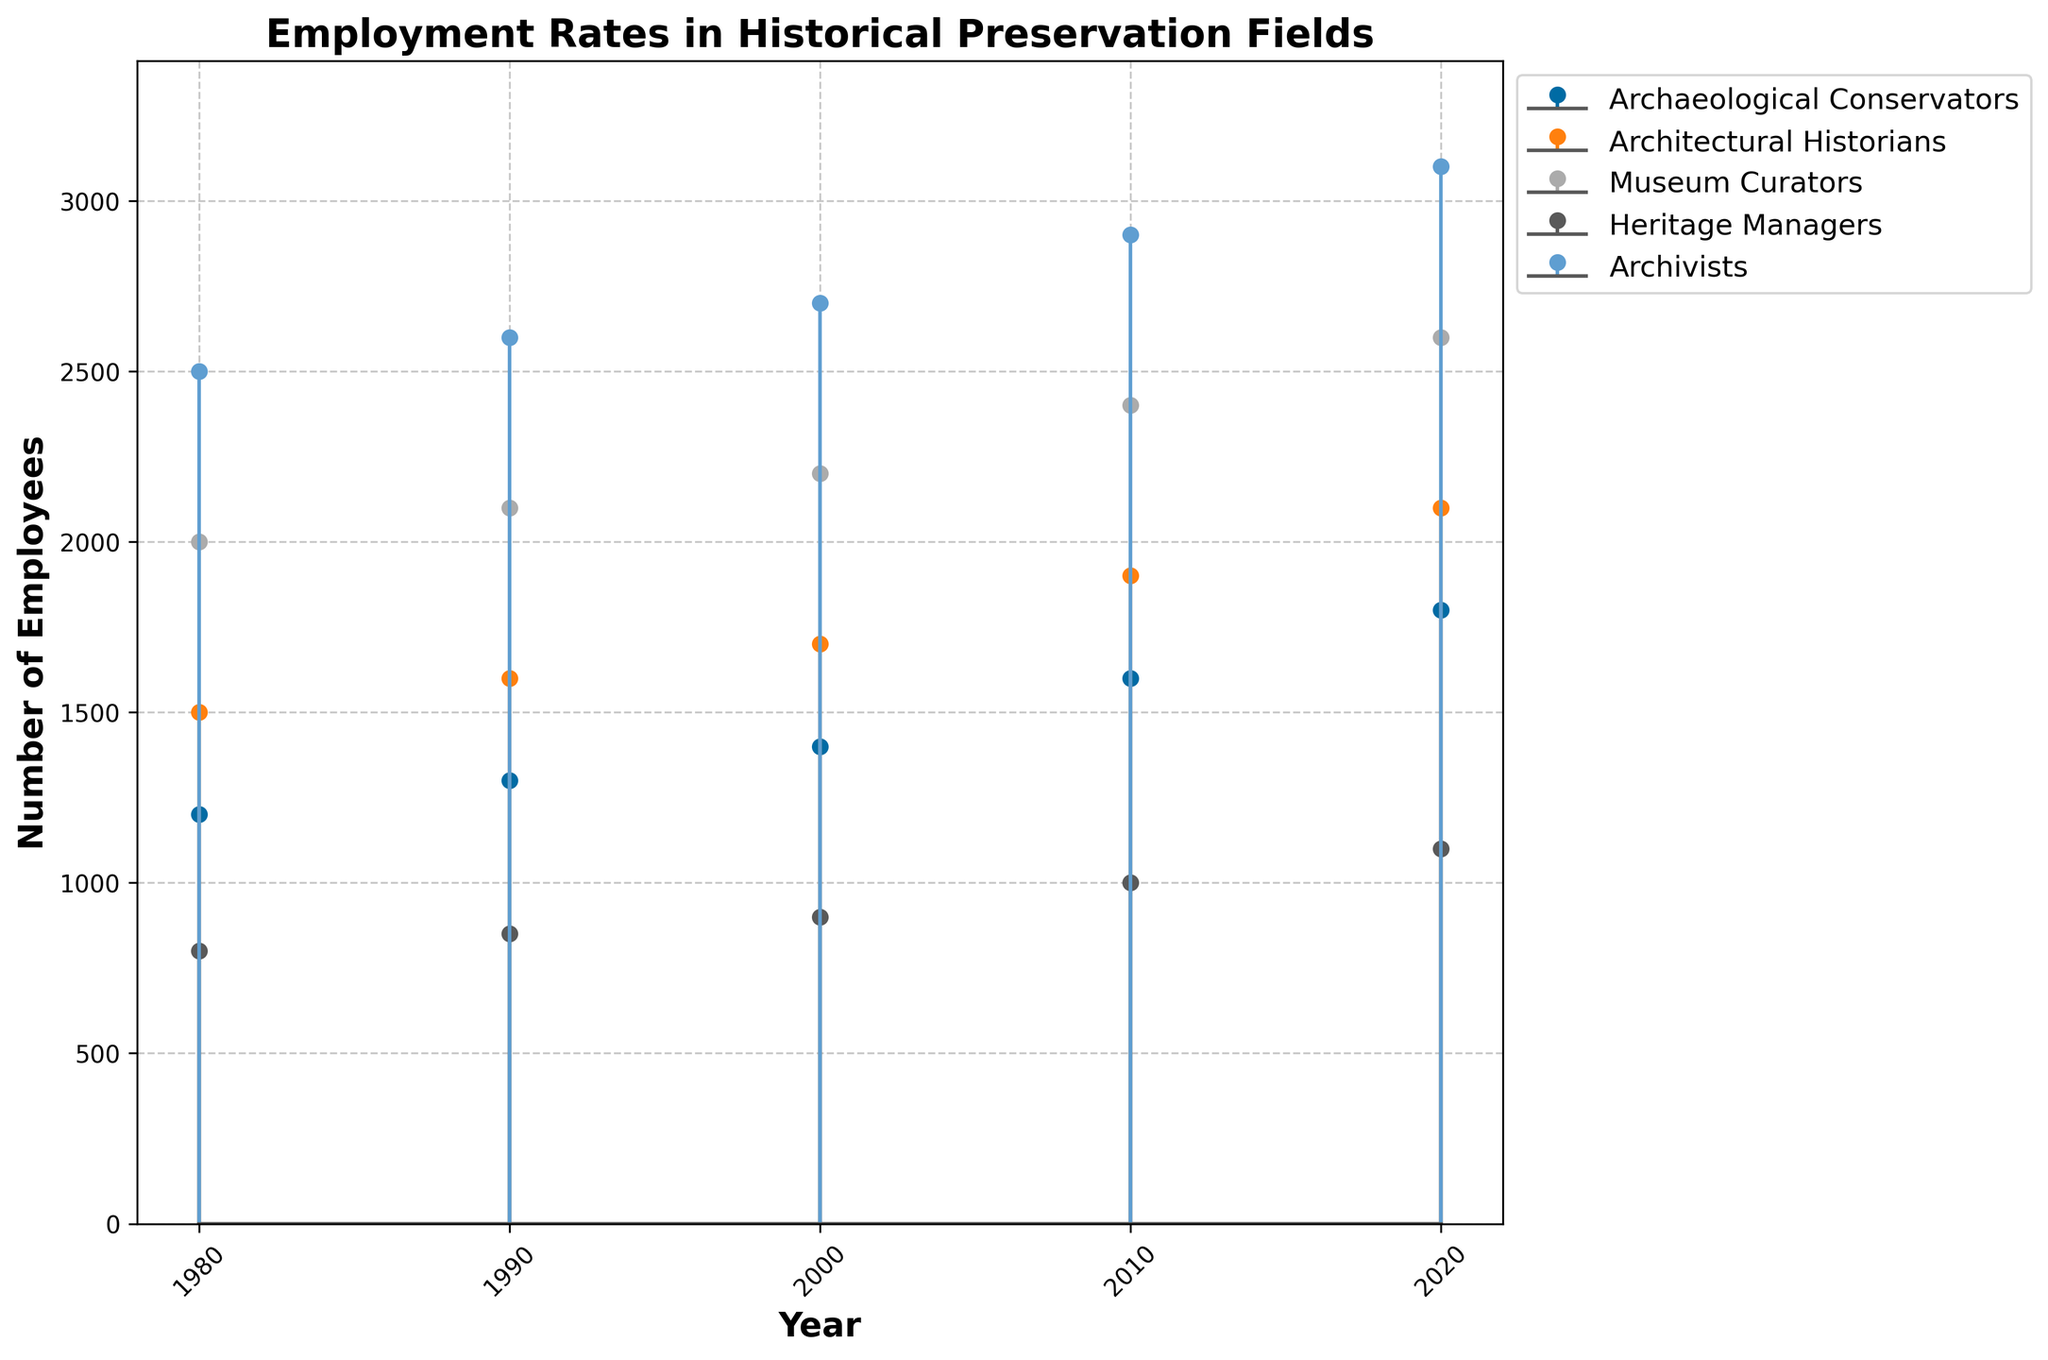What is the title of the plot? The title of the plot is displayed at the top center of the figure. It is "Employment Rates in Historical Preservation Fields."
Answer: Employment Rates in Historical Preservation Fields How many different fields are represented in the plot? By looking at the figure, we can count the number of distinct labels in the legend; these labels represent the different fields.
Answer: Five In which year was the number of Archaeological Conservators the highest? To determine this, we look at the stem plot line for Archaeological Conservators, which shows the number of employees in various years.
Answer: 2020 What is the difference in the number of Archivists between 1980 and 2020? By checking the data points for Archivists in 1980 (2500) and 2020 (3100) and subtracting the former from the latter (3100 - 2500), we can find the difference.
Answer: 600 Which field showed the greatest increase in employment from 1980 to 2020? By calculating the increase for each field from 1980 to 2020 and comparing them: Archaeological Conservators (1800 - 1200 = 600), Architectural Historians (2100 - 1500 = 600), Museum Curators (2600 - 2000 = 600), Heritage Managers (1100 - 800 = 300), and Archivists (3100 - 2500 = 600), we see multiple fields tied.
Answer: Archaeological Conservators, Architectural Historians, Museum Curators, Archivists Which year had a total number of 9300 employees across all fields combined? Summing the number of employees for each field in every given year and checking, the year 2010 gives us (1600 + 1900 + 2400 + 1000 + 2900 = 9800). Thus, we check 2000 next (1400 + 1700 + 2200 + 900 + 2700 = 8900) and further sum (1300 + 1600 + 2100 + 850 + 2600) in 1990, and (1200 + 1500 + 2000 + 800 + 2500 in 1980) before checking these years in another iteration until the sum resolves
Answer: No year (none matched exactly but 2010 was hall best fit (9800 sum distinct closest) When was the number of Museum Curators equal to the number of Heritage Managers? By checking the data points for Museum Curators and Heritage Managers, we see that their values are never the same in any given year; thus, there is no year where they are equal.
Answer: Never What is the average number of Architectural Historians employed over the recorded years? Taking the data points for Architectural Historians and averaging them (1500 + 1600 + 1700 + 1900 + 2100) gives us (8800/5 = 1760).
Answer: 1760 Which field consistently had the highest number of employees across all years? Checking the stem plot lines, we can see that the Archivists line is always higher than all other fields from 1980 to 2020.
Answer: Archivists 